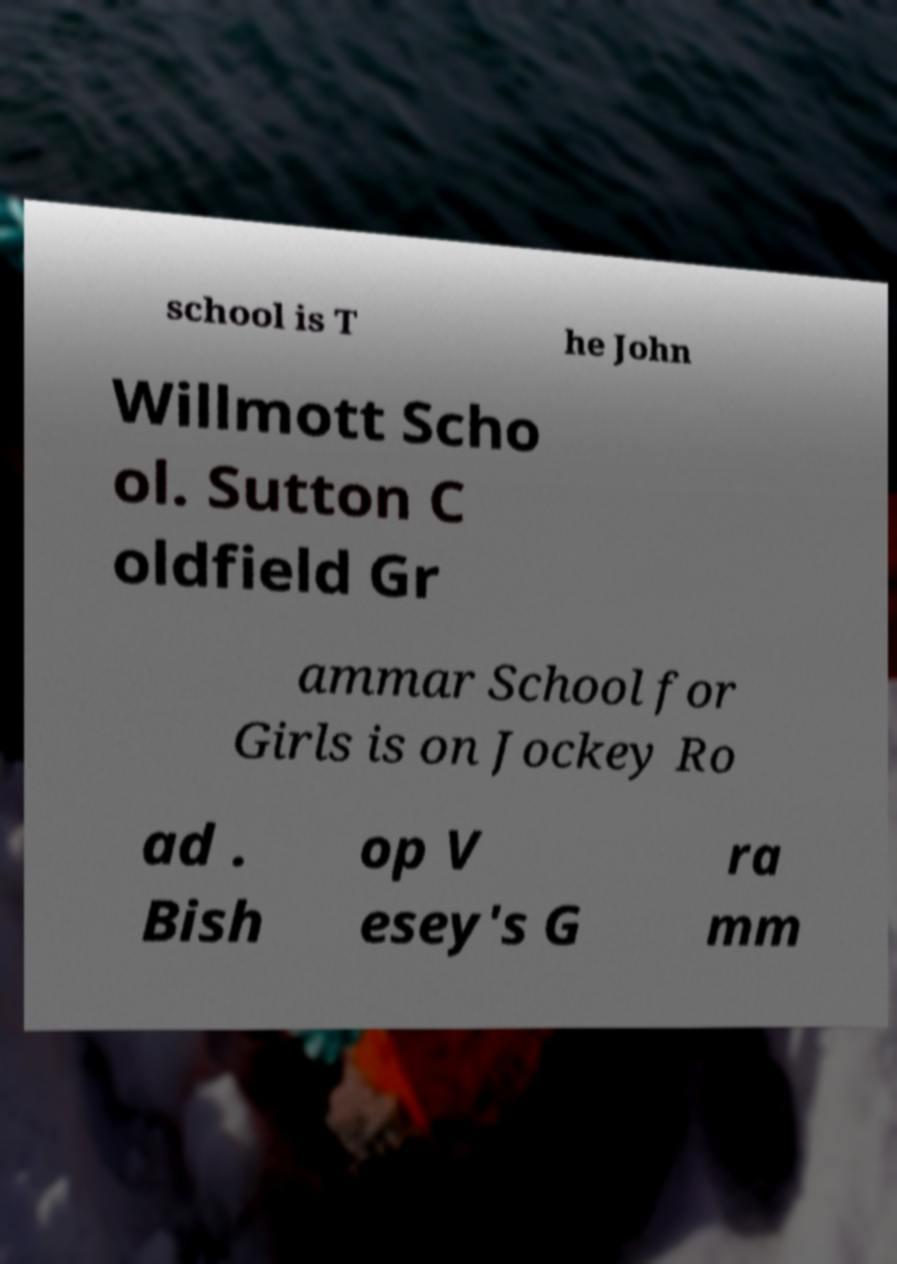Could you assist in decoding the text presented in this image and type it out clearly? school is T he John Willmott Scho ol. Sutton C oldfield Gr ammar School for Girls is on Jockey Ro ad . Bish op V esey's G ra mm 